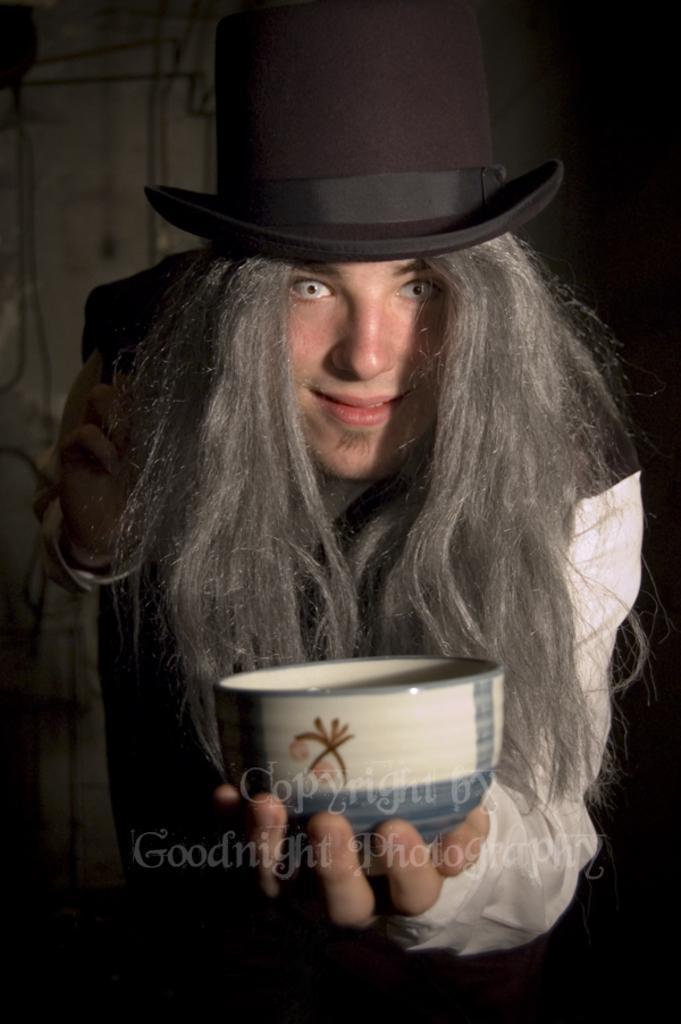In one or two sentences, can you explain what this image depicts? In this picture we can see a person with a hat and the person is holding a bowl. Behind the person there is a dark background and on the image there is a watermark. 